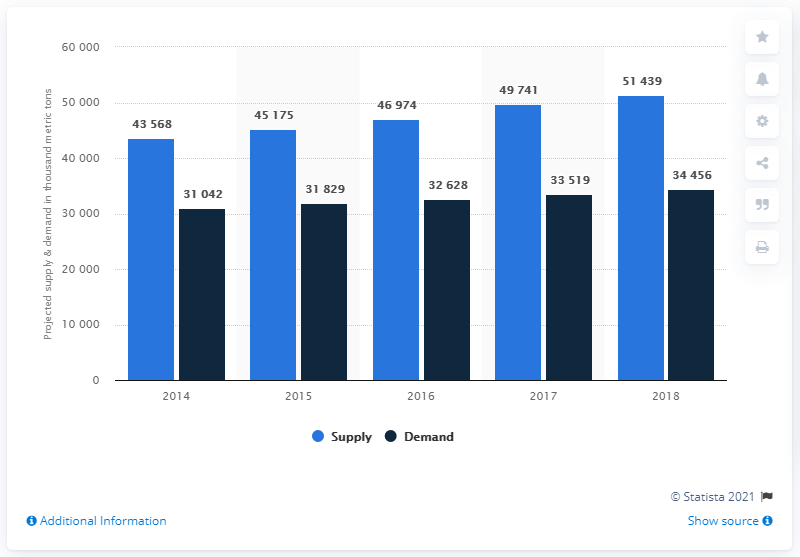Identify some key points in this picture. The global supply of potash is projected to be 51,439 metric tons in 2018. The projected global demand of potash in 2018 is expected to be 34,456. 